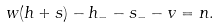<formula> <loc_0><loc_0><loc_500><loc_500>w ( h + s ) - h _ { - } - s _ { - } - v = n .</formula> 